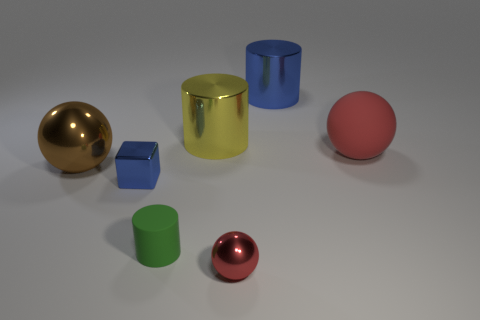Subtract all big red balls. How many balls are left? 2 Subtract all brown cylinders. How many red spheres are left? 2 Add 1 small green cylinders. How many objects exist? 8 Subtract 1 spheres. How many spheres are left? 2 Subtract all blocks. How many objects are left? 6 Subtract all purple balls. Subtract all red cubes. How many balls are left? 3 Subtract all tiny green matte objects. Subtract all matte spheres. How many objects are left? 5 Add 6 green rubber cylinders. How many green rubber cylinders are left? 7 Add 4 small blue metallic objects. How many small blue metallic objects exist? 5 Subtract 2 red spheres. How many objects are left? 5 